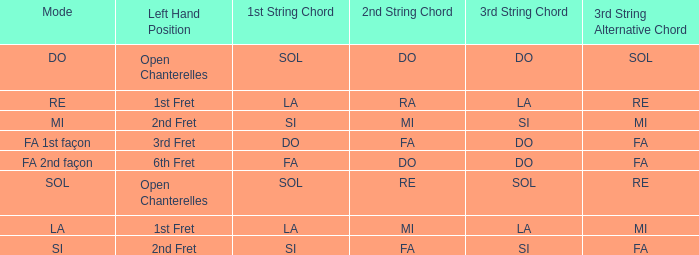For the 2nd string of Ra what is the Depart de la main gauche? 1st case. 